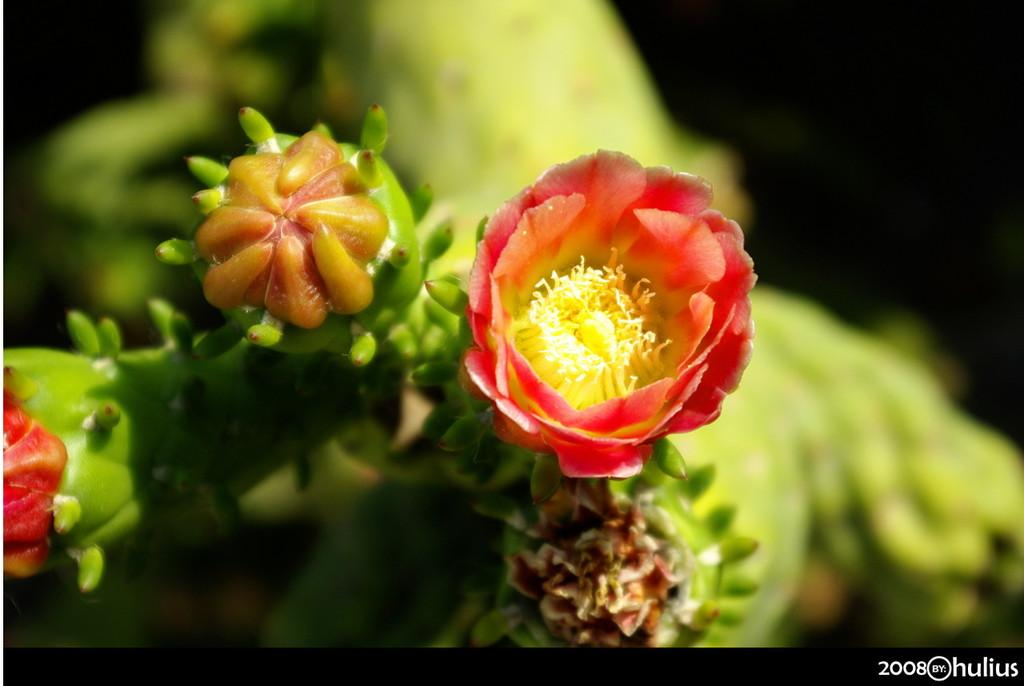What type of plant is in the image? There is a flower plant in the image. What color are the flowers on the plant? The flowers on the plant are red. Can you describe any additional features of the image? There is a watermark in the image, and the background is blurred. How many horses are visible in the image? There are no horses present in the image; it features a flower plant with red flowers. What type of rifle is being used by the person in the image? There is no person or rifle present in the image. 